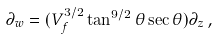<formula> <loc_0><loc_0><loc_500><loc_500>\partial _ { w } = ( V _ { f } ^ { 3 / 2 } \tan ^ { 9 / 2 } \theta \sec \theta ) \partial _ { z } \, ,</formula> 